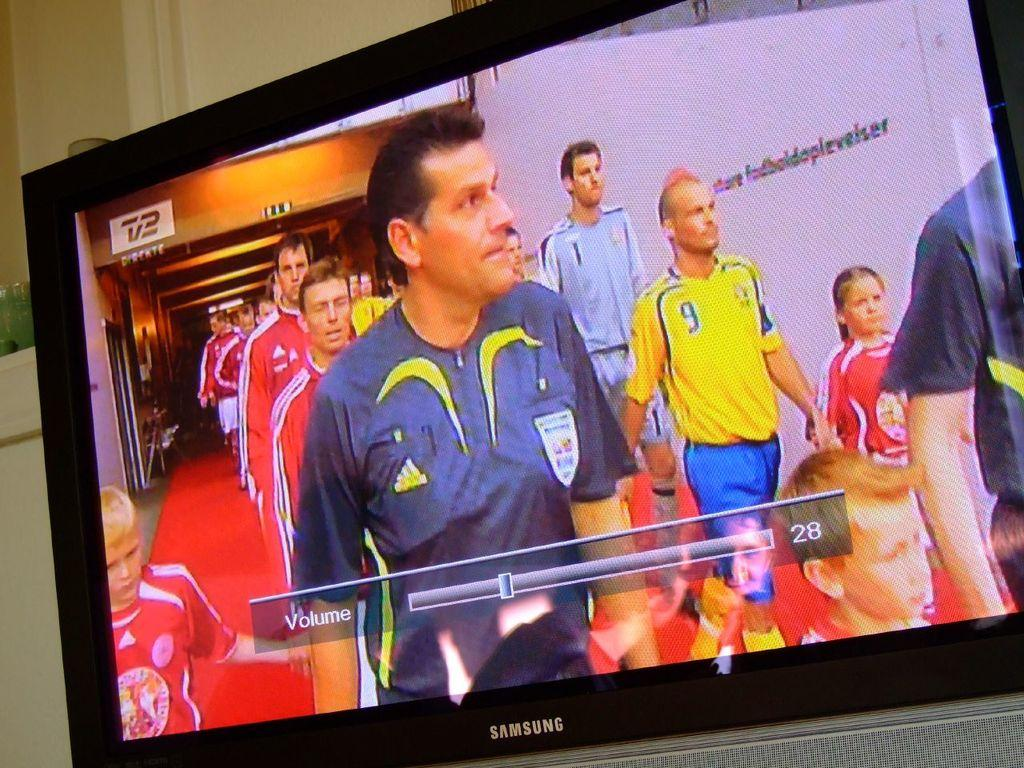Provide a one-sentence caption for the provided image. A tv is displayed with the volume at 28. 